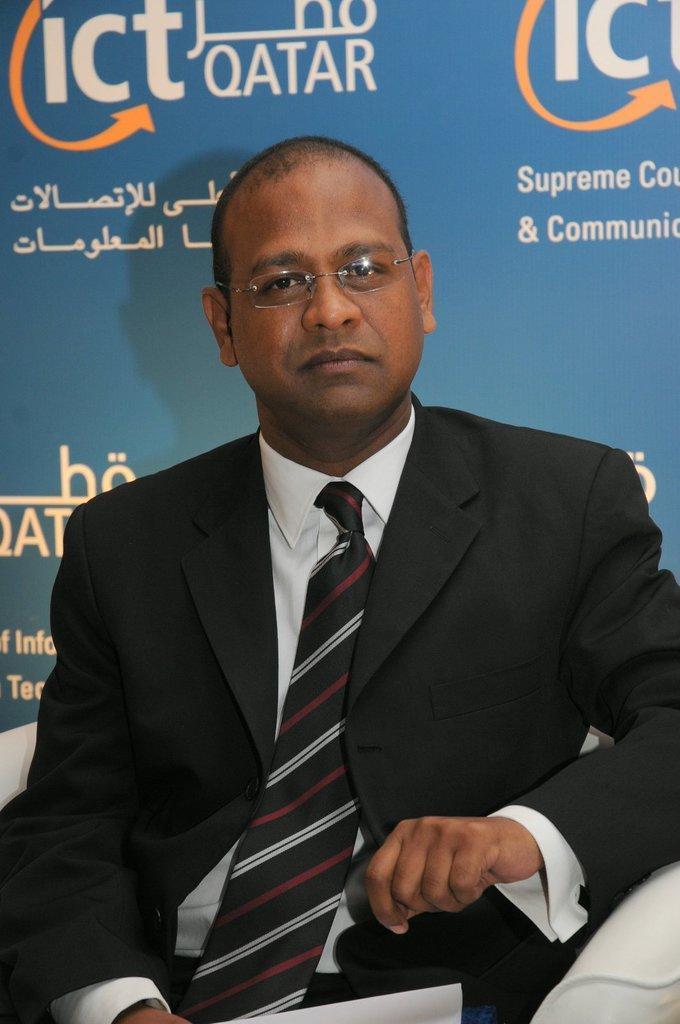In one or two sentences, can you explain what this image depicts? In this picture there is a person in black suit sitting on a couch holding a people. Behind him there is a banner, on the banner there is text. 